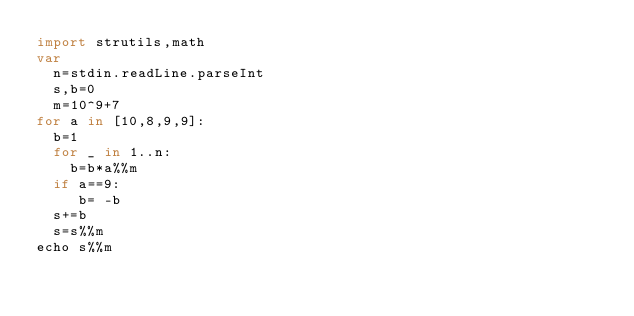<code> <loc_0><loc_0><loc_500><loc_500><_Nim_>import strutils,math
var
  n=stdin.readLine.parseInt
  s,b=0
  m=10^9+7
for a in [10,8,9,9]:
  b=1
  for _ in 1..n:
    b=b*a%%m
  if a==9:
     b= -b
  s+=b
  s=s%%m
echo s%%m</code> 